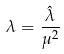<formula> <loc_0><loc_0><loc_500><loc_500>\lambda = \frac { \hat { \lambda } } { \mu ^ { 2 } }</formula> 